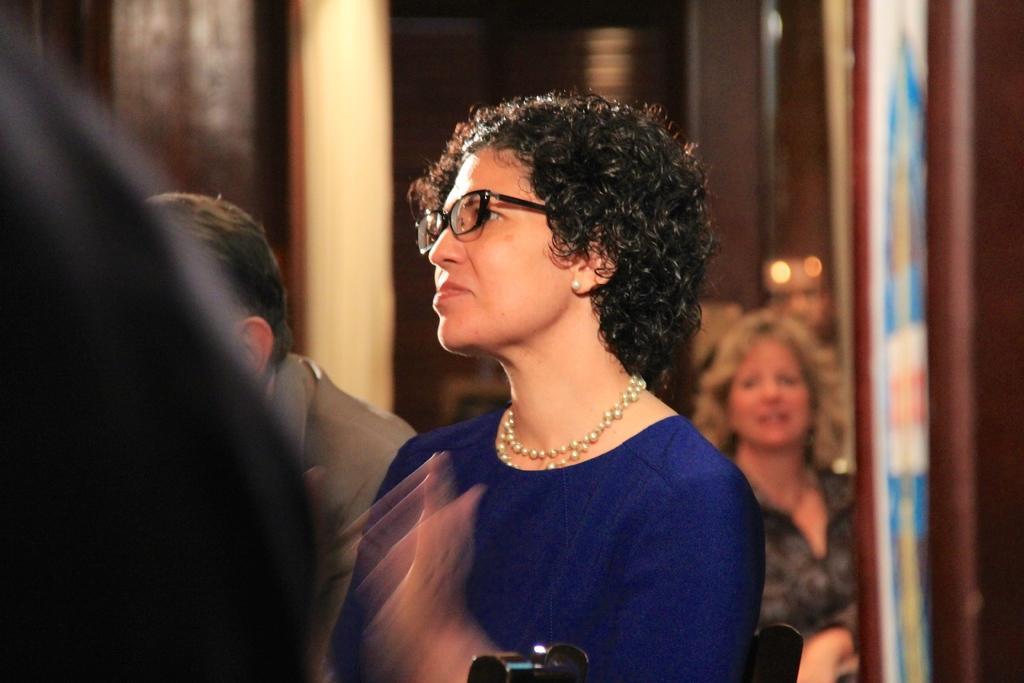Describe this image in one or two sentences. In this picture we can see a woman wearing spectacles, around we can see few people. 